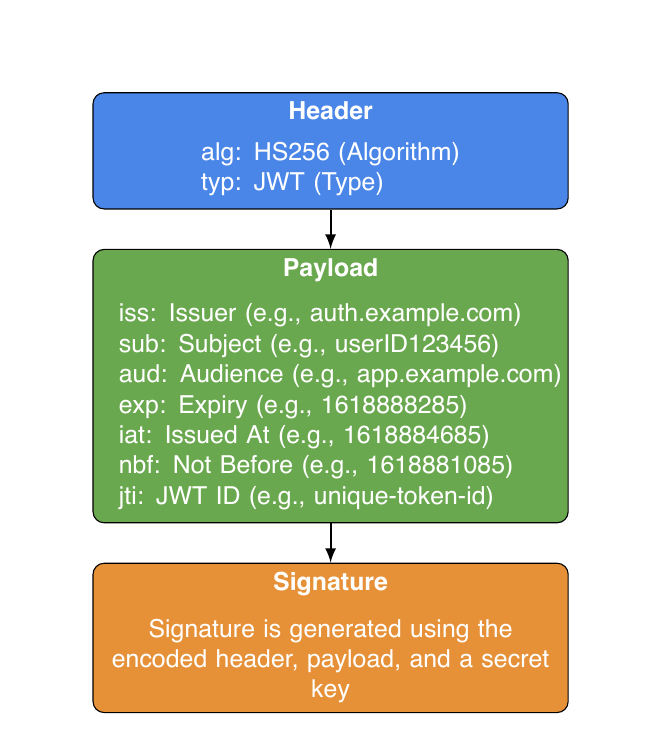What are the two main components in the header of a JWT? The header contains two main components: the algorithm used (alg) and the type (typ). In this diagram, the alg is HS256 and typ is JWT.
Answer: alg and typ What is the issuer claim in the payload section? The issuer claim (iss) specifies the entity that issued the token. According to the diagram, the example provided is auth.example.com.
Answer: auth.example.com How many claims are listed in the payload section? In the payload section, there are six claims listed: iss, sub, aud, exp, iat, nbf, and jti. Counting these claims gives a total of six.
Answer: six What does the signature section indicate about its generation? The signature section indicates that the signature is generated using the encoded header, payload, and a secret key. This implies that all three components are crucial for the integrity of the JWT.
Answer: generated using encoded header, payload, and a secret key How is the relationship between the header and the payload illustrated in the diagram? The relationship is illustrated by a thick arrow pointing from the header to the payload, indicating that the header precedes and leads into the payload, part of the structure of a JWT.
Answer: a thick arrow What purpose does the 'aud' claim serve in the payload? The 'aud' claim identifies the audience that the token is intended for. In the diagram, the example provided is app.example.com, suggesting that it specifies who can use the token.
Answer: audience Which claim indicates when the token was issued? The claim that indicates when the token was issued is the issued at claim (iat), which has an example value given in the diagram.
Answer: iat In what order are the sections of a JSON Web Token presented in the diagram? The sections of a JSON Web Token are presented in the following order: Header, Payload, Signature. This sequential arrangement shows their hierarchy and interdependence.
Answer: Header, Payload, Signature What is the color coding used in the diagram for the payload section? The color coding for the payload section is green, as indicated by the diagram using a specific green shade for that section.
Answer: green 